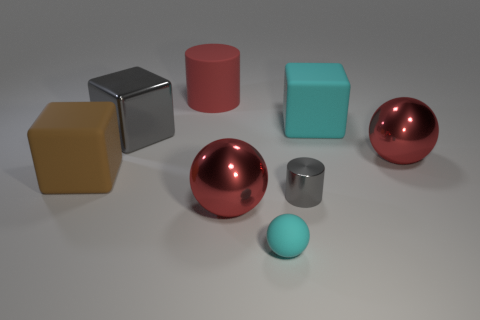What material is the tiny cylinder that is the same color as the big shiny cube?
Offer a very short reply. Metal. Are there any metal things of the same shape as the red rubber thing?
Your response must be concise. Yes. How many other things are the same shape as the small gray object?
Your answer should be compact. 1. Do the small metallic thing and the large metallic cube have the same color?
Offer a very short reply. Yes. Are there more large red matte cylinders than big red metal things?
Ensure brevity in your answer.  No. How many small objects are either cyan blocks or cyan matte balls?
Keep it short and to the point. 1. What number of other objects are there of the same color as the metallic cube?
Offer a very short reply. 1. How many other cubes have the same material as the brown cube?
Your response must be concise. 1. There is a big shiny sphere that is left of the big cyan rubber object; is its color the same as the matte cylinder?
Your answer should be very brief. Yes. How many green things are either metal spheres or small spheres?
Offer a very short reply. 0. 